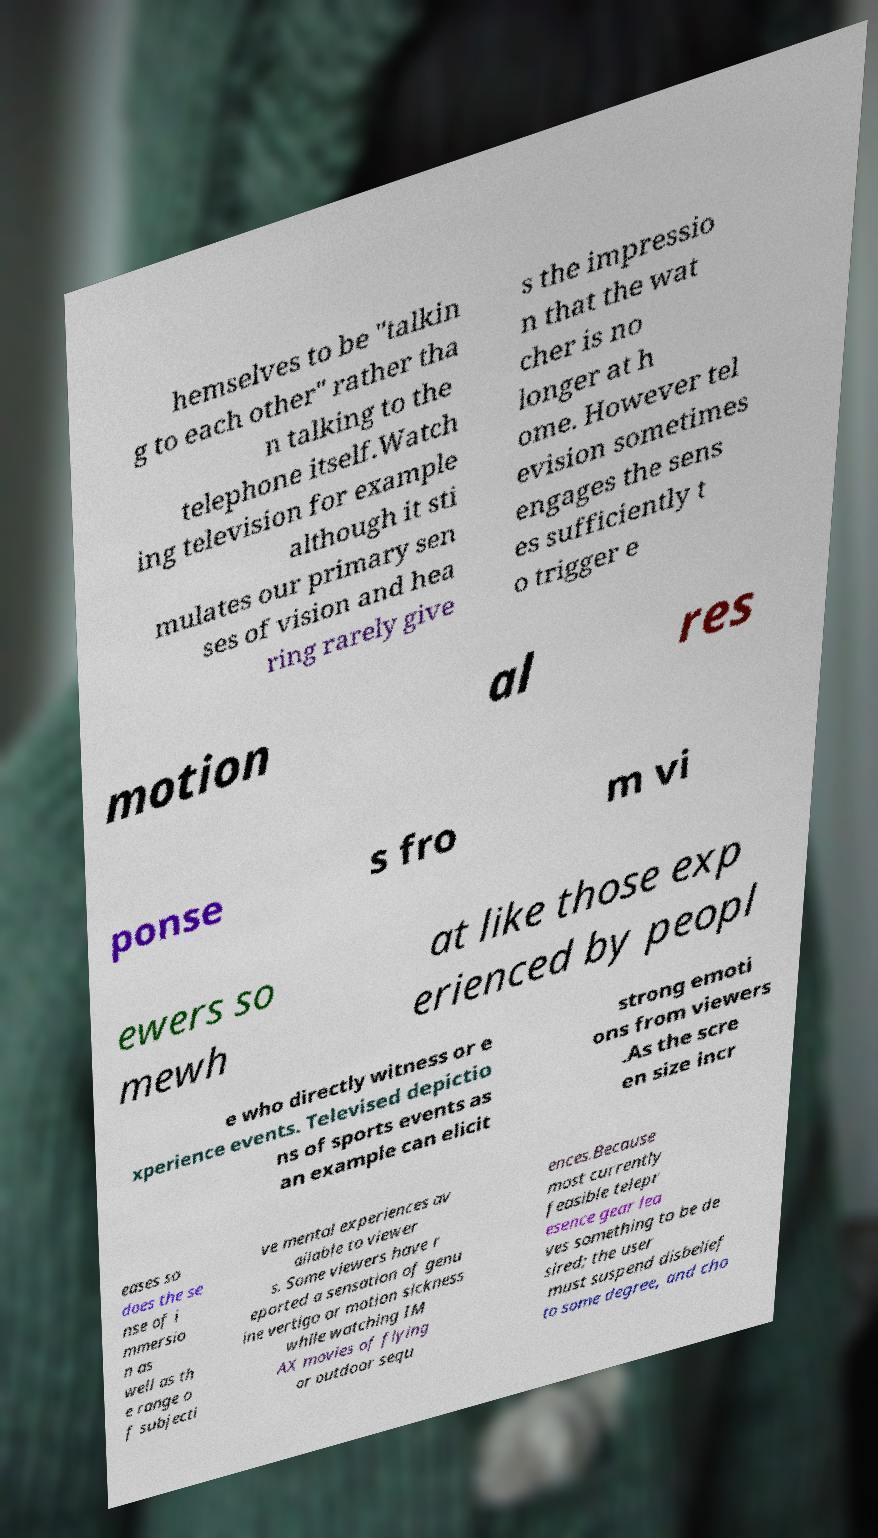Can you accurately transcribe the text from the provided image for me? hemselves to be "talkin g to each other" rather tha n talking to the telephone itself.Watch ing television for example although it sti mulates our primary sen ses of vision and hea ring rarely give s the impressio n that the wat cher is no longer at h ome. However tel evision sometimes engages the sens es sufficiently t o trigger e motion al res ponse s fro m vi ewers so mewh at like those exp erienced by peopl e who directly witness or e xperience events. Televised depictio ns of sports events as an example can elicit strong emoti ons from viewers .As the scre en size incr eases so does the se nse of i mmersio n as well as th e range o f subjecti ve mental experiences av ailable to viewer s. Some viewers have r eported a sensation of genu ine vertigo or motion sickness while watching IM AX movies of flying or outdoor sequ ences.Because most currently feasible telepr esence gear lea ves something to be de sired; the user must suspend disbelief to some degree, and cho 